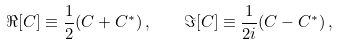Convert formula to latex. <formula><loc_0><loc_0><loc_500><loc_500>\Re [ C ] \equiv \frac { 1 } { 2 } ( C + C ^ { * } ) \, , \quad \Im [ C ] \equiv \frac { 1 } { 2 i } ( C - C ^ { * } ) \, ,</formula> 